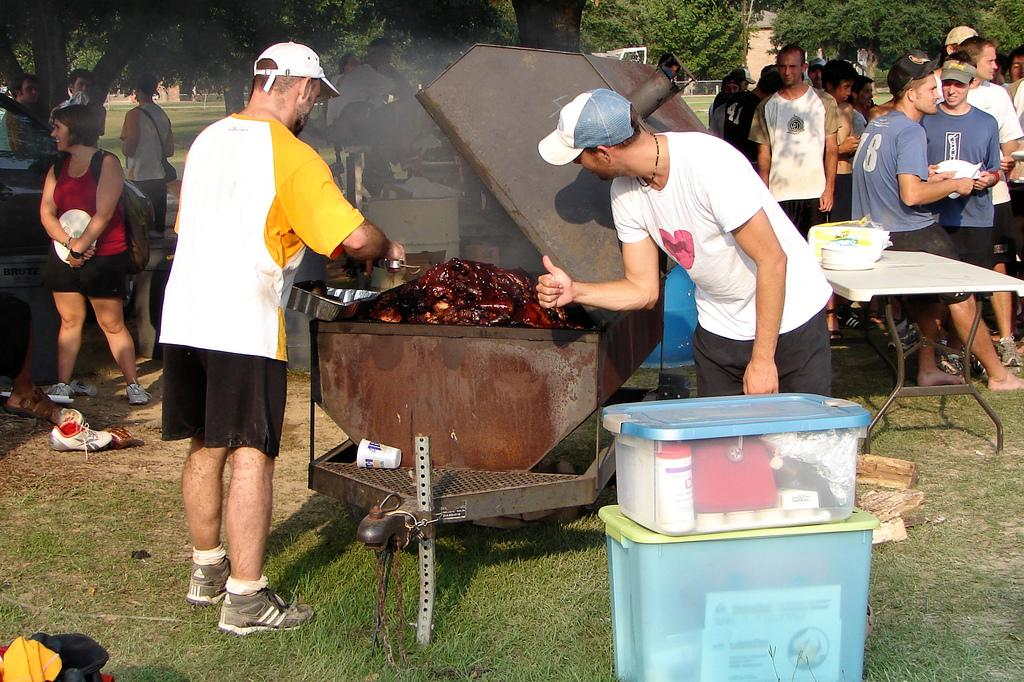<image>
Share a concise interpretation of the image provided. a man wearing some adidas shoes and black shorts 